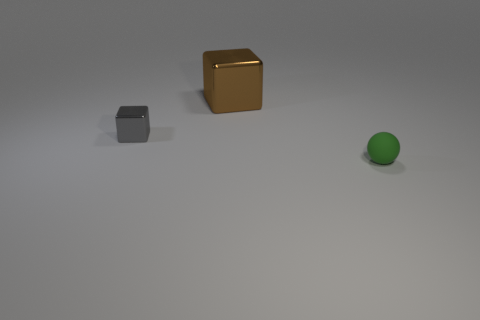Add 2 red blocks. How many objects exist? 5 Subtract all spheres. How many objects are left? 2 Add 2 large green matte cylinders. How many large green matte cylinders exist? 2 Subtract 0 blue cylinders. How many objects are left? 3 Subtract all small green things. Subtract all large purple spheres. How many objects are left? 2 Add 2 large cubes. How many large cubes are left? 3 